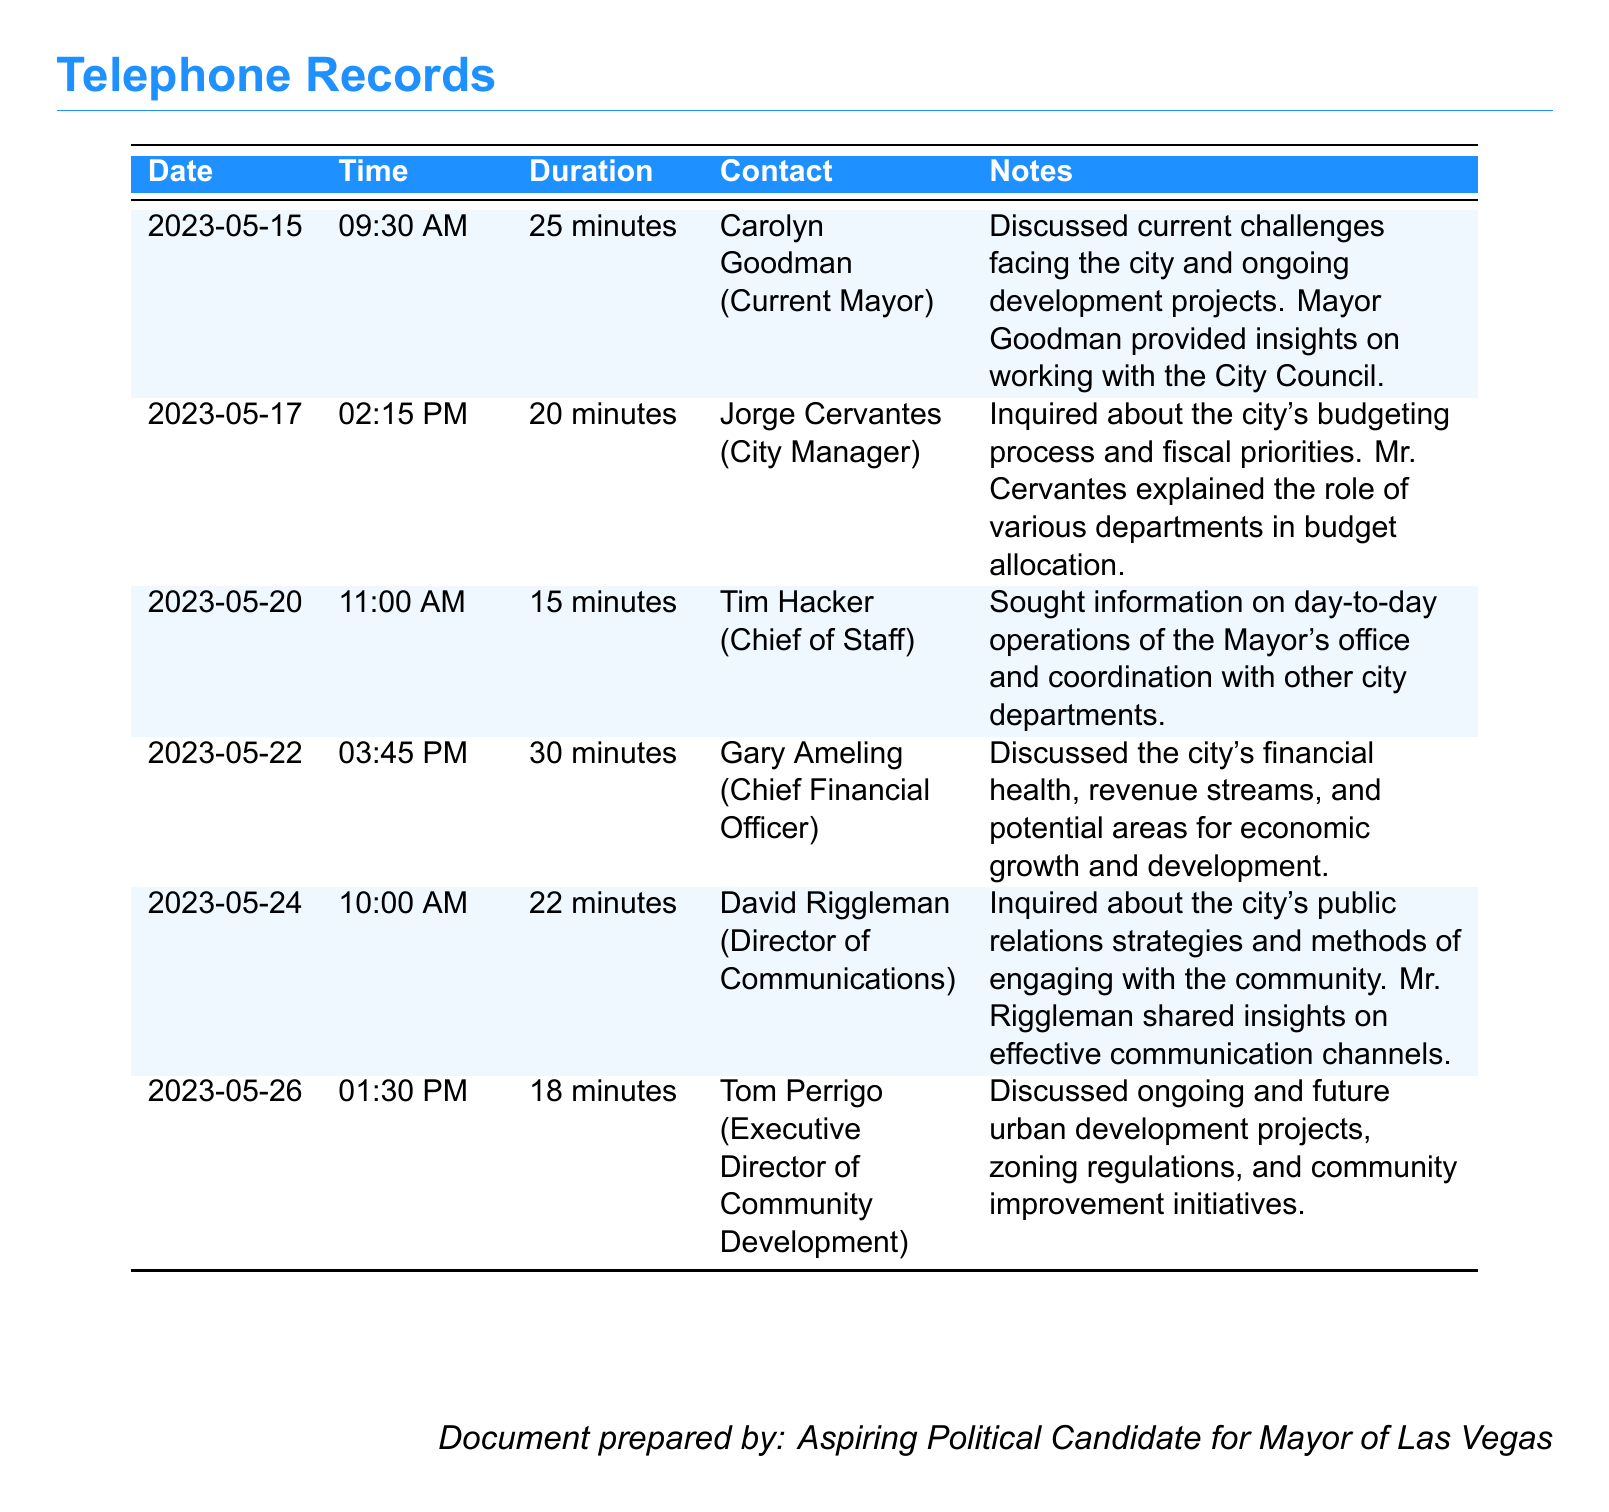What date was the call with Carolyn Goodman? The date of the call with Carolyn Goodman is provided in the table under the "Date" column corresponding to her name.
Answer: 2023-05-15 How long was the conversation with Jorge Cervantes? The duration of the conversation with Jorge Cervantes is located under the "Duration" column next to his name.
Answer: 20 minutes Who is the Chief Financial Officer mentioned in the records? The name of the Chief Financial Officer is included in the contact information next to the corresponding notes in the table.
Answer: Gary Ameling What topics were discussed with the Chief of Staff? The topics discussed with Tim Hacker are noted under the "Notes" section associated with his name in the document.
Answer: Day-to-day operations and coordination Which city department did Tom Perrigo lead? The department led by Tom Perrigo is mentioned in his title, which is provided in the "Contact" column.
Answer: Community Development What was the main focus of the conversation with David Riggleman? The main focus of the conversation with David Riggleman is outlined in the notes related to his name in the document.
Answer: Public relations strategies How many minutes did the call with Gary Ameling last? The duration of the call with Gary Ameling can be found in the "Duration" column next to his entry.
Answer: 30 minutes Which official shared insights on budget allocation? The official who shared insights on budget allocation is specified in the notes related to Jorge Cervantes in the document.
Answer: Jorge Cervantes What color is used for the header in the table? The color used for the header in the table is mentioned in the document detailing the styles and formatting.
Answer: Headercolor 